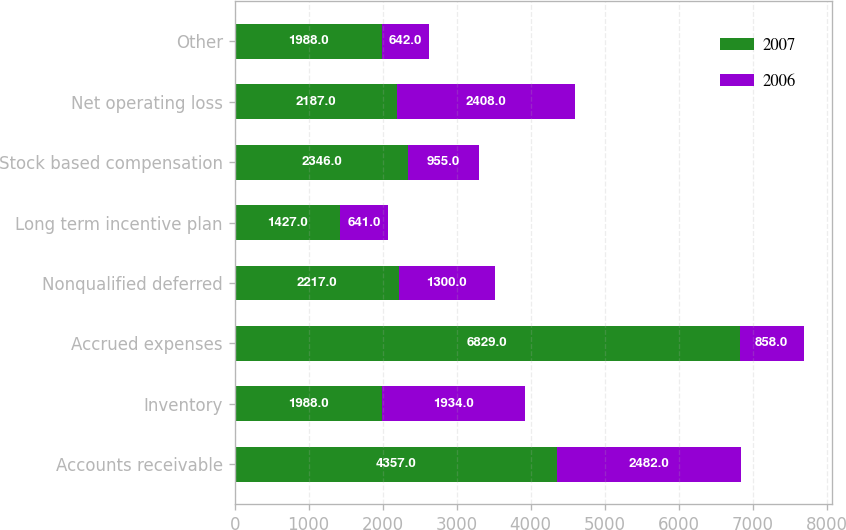Convert chart to OTSL. <chart><loc_0><loc_0><loc_500><loc_500><stacked_bar_chart><ecel><fcel>Accounts receivable<fcel>Inventory<fcel>Accrued expenses<fcel>Nonqualified deferred<fcel>Long term incentive plan<fcel>Stock based compensation<fcel>Net operating loss<fcel>Other<nl><fcel>2007<fcel>4357<fcel>1988<fcel>6829<fcel>2217<fcel>1427<fcel>2346<fcel>2187<fcel>1988<nl><fcel>2006<fcel>2482<fcel>1934<fcel>858<fcel>1300<fcel>641<fcel>955<fcel>2408<fcel>642<nl></chart> 